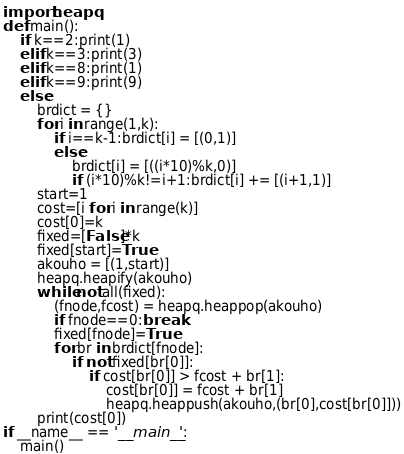<code> <loc_0><loc_0><loc_500><loc_500><_Python_>import heapq
def main():
    if k==2:print(1)
    elif k==3:print(3)
    elif k==8:print(1)
    elif k==9:print(9)
    else:
        brdict = {}
        for i in range(1,k):
            if i==k-1:brdict[i] = [(0,1)]
            else:
                brdict[i] = [((i*10)%k,0)]
                if (i*10)%k!=i+1:brdict[i] += [(i+1,1)]
        start=1
        cost=[i for i in range(k)]
        cost[0]=k
        fixed=[False]*k
        fixed[start]=True
        akouho = [(1,start)]
        heapq.heapify(akouho)
        while not all(fixed):
            (fnode,fcost) = heapq.heappop(akouho)
            if fnode==0:break
            fixed[fnode]=True
            for br in brdict[fnode]:
                if not fixed[br[0]]:
                    if cost[br[0]] > fcost + br[1]:
                        cost[br[0]] = fcost + br[1]
                        heapq.heappush(akouho,(br[0],cost[br[0]]))
        print(cost[0])
if __name__ == '__main__':
    main()</code> 